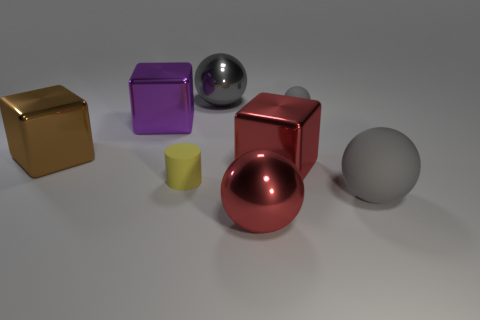Subtract all gray cubes. How many gray balls are left? 3 Add 1 gray things. How many objects exist? 9 Subtract all blocks. How many objects are left? 5 Subtract 0 cyan blocks. How many objects are left? 8 Subtract all red blocks. Subtract all rubber spheres. How many objects are left? 5 Add 7 cylinders. How many cylinders are left? 8 Add 5 red cubes. How many red cubes exist? 6 